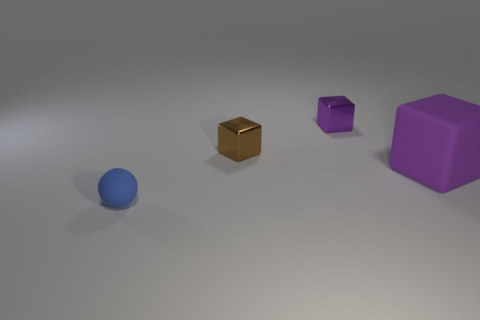Add 4 big things. How many objects exist? 8 Subtract 0 purple spheres. How many objects are left? 4 Subtract all spheres. How many objects are left? 3 Subtract all small shiny blocks. Subtract all big purple rubber things. How many objects are left? 1 Add 3 tiny purple objects. How many tiny purple objects are left? 4 Add 4 brown blocks. How many brown blocks exist? 5 